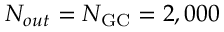<formula> <loc_0><loc_0><loc_500><loc_500>N _ { o u t } = N _ { G C } = 2 , 0 0 0</formula> 